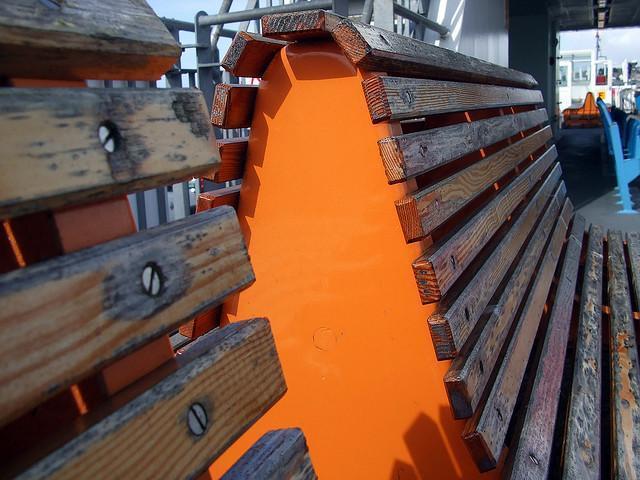How many benches are in the photo?
Give a very brief answer. 2. How many motorcycles have two helmets?
Give a very brief answer. 0. 